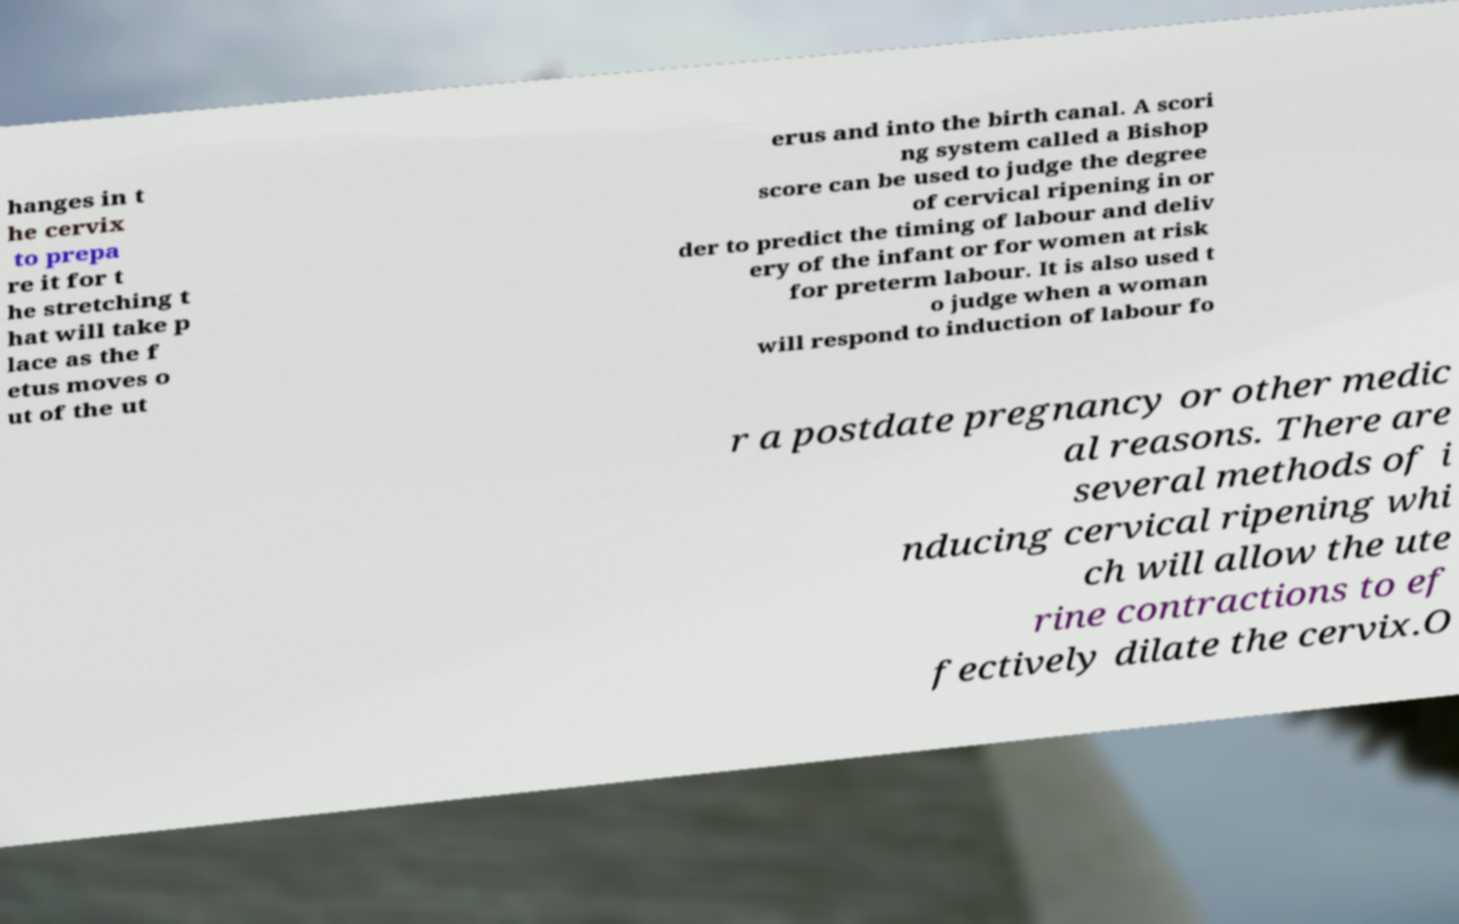Please read and relay the text visible in this image. What does it say? hanges in t he cervix to prepa re it for t he stretching t hat will take p lace as the f etus moves o ut of the ut erus and into the birth canal. A scori ng system called a Bishop score can be used to judge the degree of cervical ripening in or der to predict the timing of labour and deliv ery of the infant or for women at risk for preterm labour. It is also used t o judge when a woman will respond to induction of labour fo r a postdate pregnancy or other medic al reasons. There are several methods of i nducing cervical ripening whi ch will allow the ute rine contractions to ef fectively dilate the cervix.O 